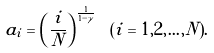<formula> <loc_0><loc_0><loc_500><loc_500>a _ { i } = \left ( \frac { i } { N } \right ) ^ { \frac { 1 } { 1 - \gamma } } \ ( i = 1 , 2 , \dots , N ) .</formula> 